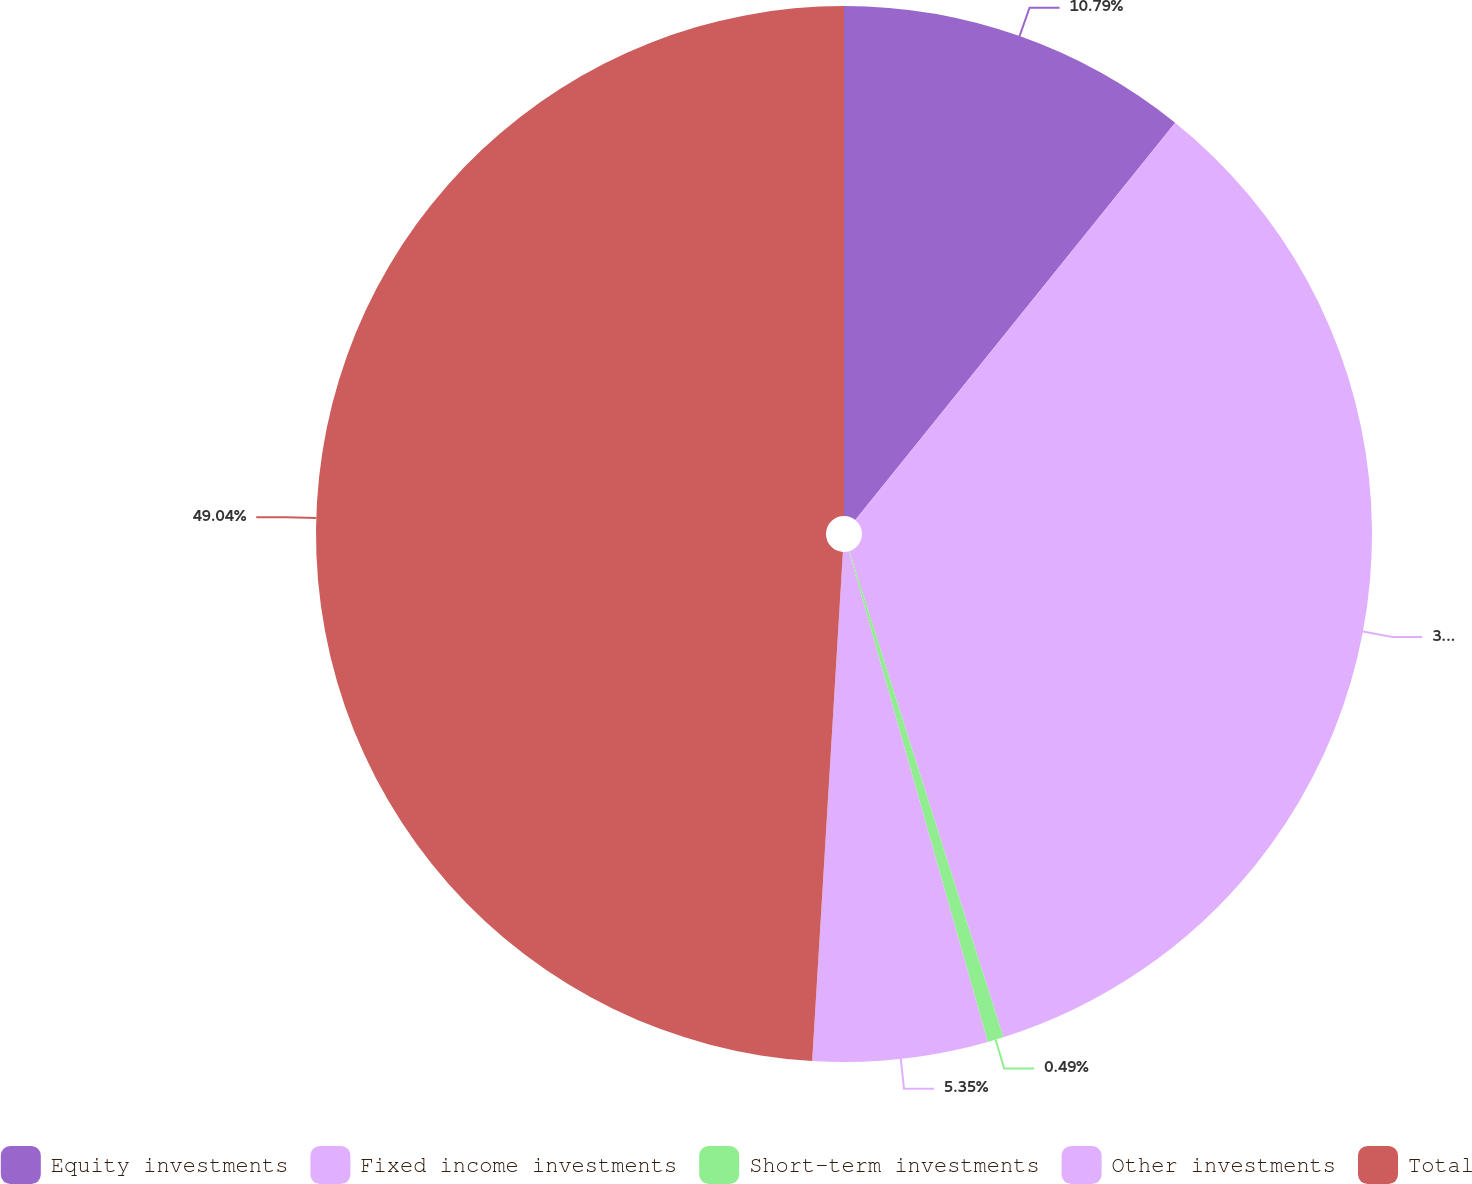Convert chart. <chart><loc_0><loc_0><loc_500><loc_500><pie_chart><fcel>Equity investments<fcel>Fixed income investments<fcel>Short-term investments<fcel>Other investments<fcel>Total<nl><fcel>10.79%<fcel>34.33%<fcel>0.49%<fcel>5.35%<fcel>49.04%<nl></chart> 